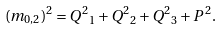Convert formula to latex. <formula><loc_0><loc_0><loc_500><loc_500>( m _ { 0 , 2 } ) ^ { 2 } = { Q ^ { 2 } } _ { 1 } + { Q ^ { 2 } } _ { 2 } + { Q ^ { 2 } } _ { 3 } + P ^ { 2 } .</formula> 